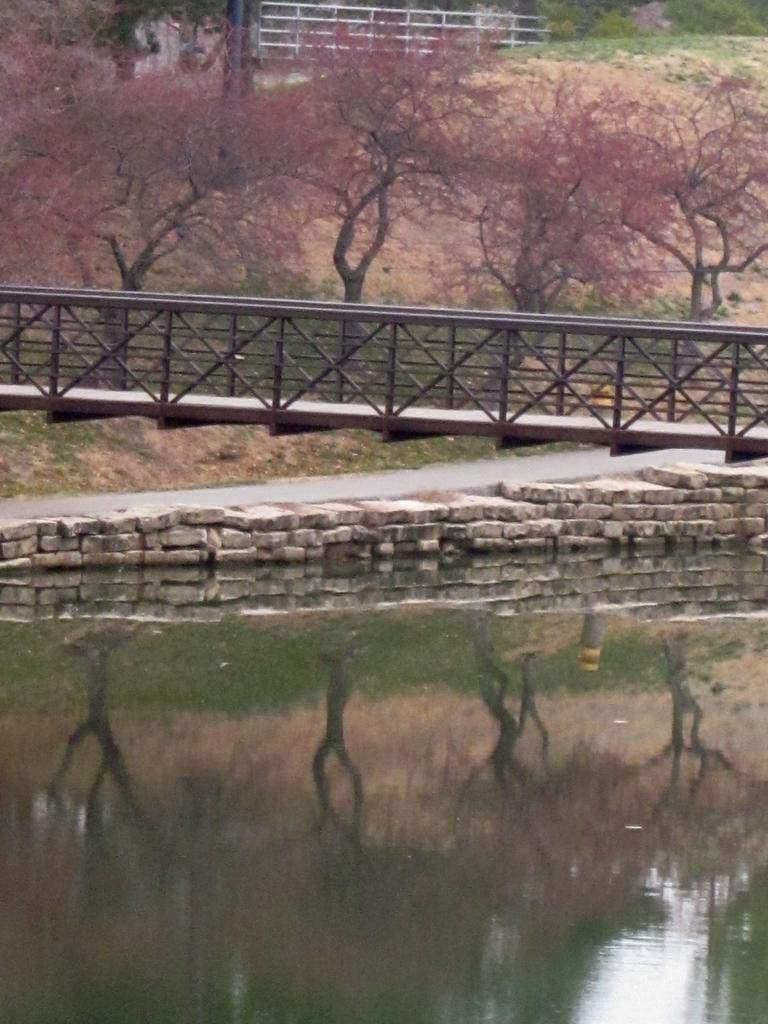What type of structure is present in the image? There is a bridge in the image. What can be seen on the bridge? There is a walkway on the bridge. What type of material is used for the wall in the image? There is a stone wall in the image. What is visible in the water? There is water visible in the image, and there are reflections on the water. What can be seen in the background of the image? The background of the image includes trees, poles, and rods. What type of linen is used to cover the trees in the image? There is no linen present in the image, and the trees are not covered. What is the profit made from the rods in the background of the image? There is no information about profit in the image, as it is focused on the structures and elements present. 